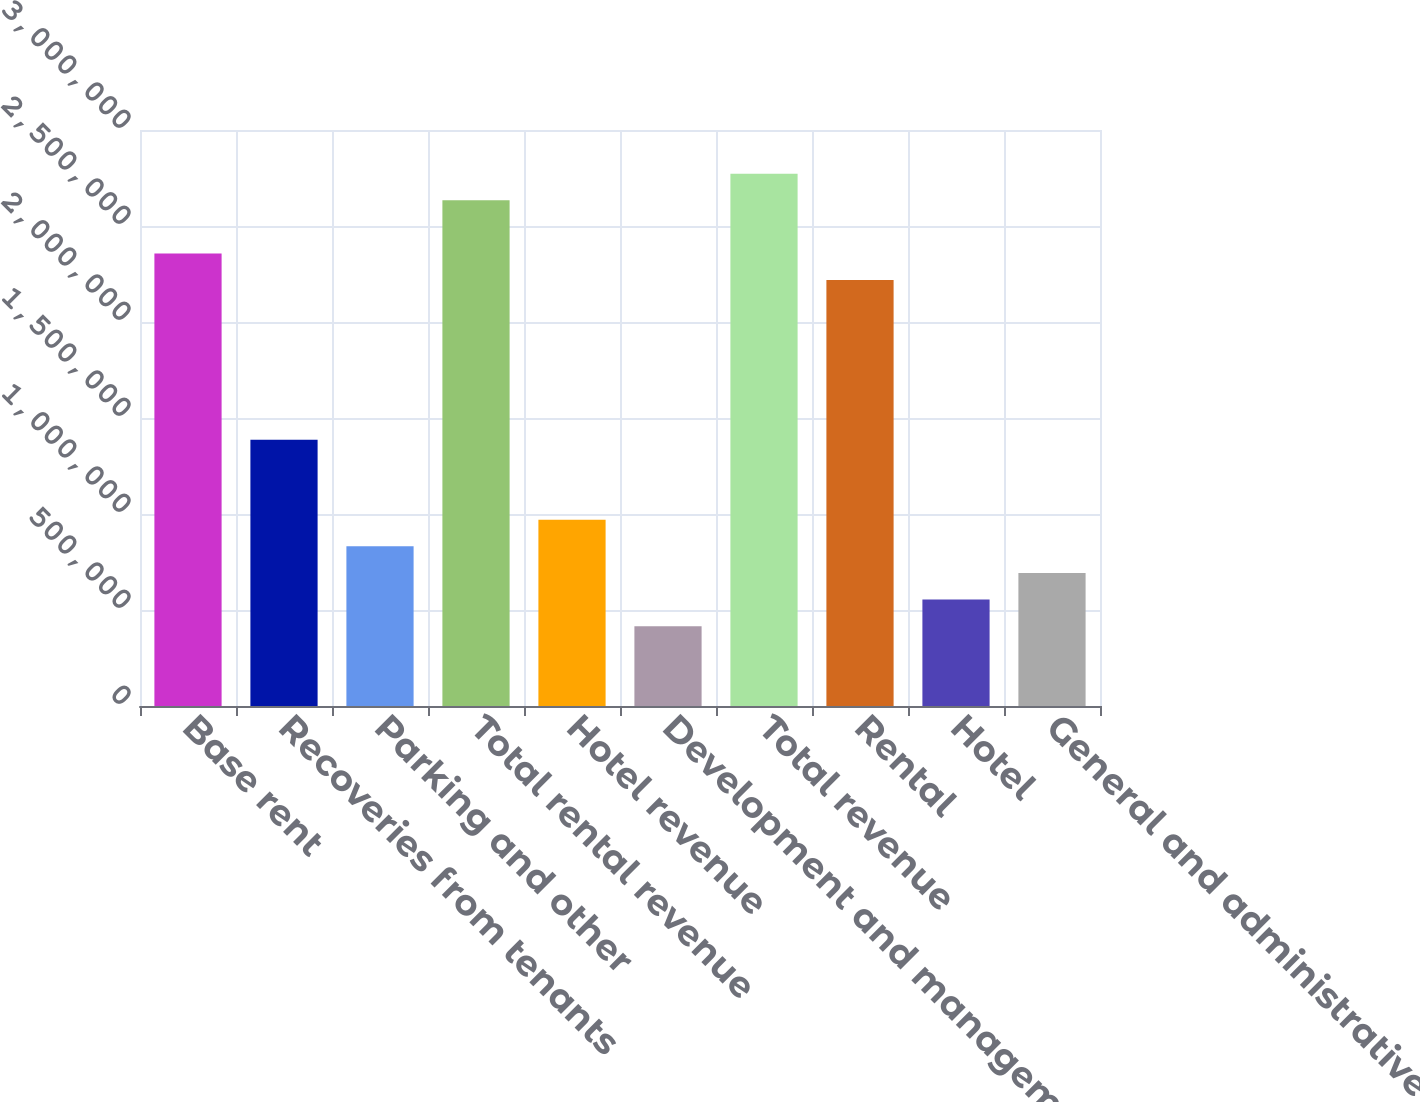Convert chart to OTSL. <chart><loc_0><loc_0><loc_500><loc_500><bar_chart><fcel>Base rent<fcel>Recoveries from tenants<fcel>Parking and other<fcel>Total rental revenue<fcel>Hotel revenue<fcel>Development and management<fcel>Total revenue<fcel>Rental<fcel>Hotel<fcel>General and administrative<nl><fcel>2.35679e+06<fcel>1.38635e+06<fcel>831809<fcel>2.63406e+06<fcel>970443<fcel>415905<fcel>2.77269e+06<fcel>2.21815e+06<fcel>554540<fcel>693174<nl></chart> 